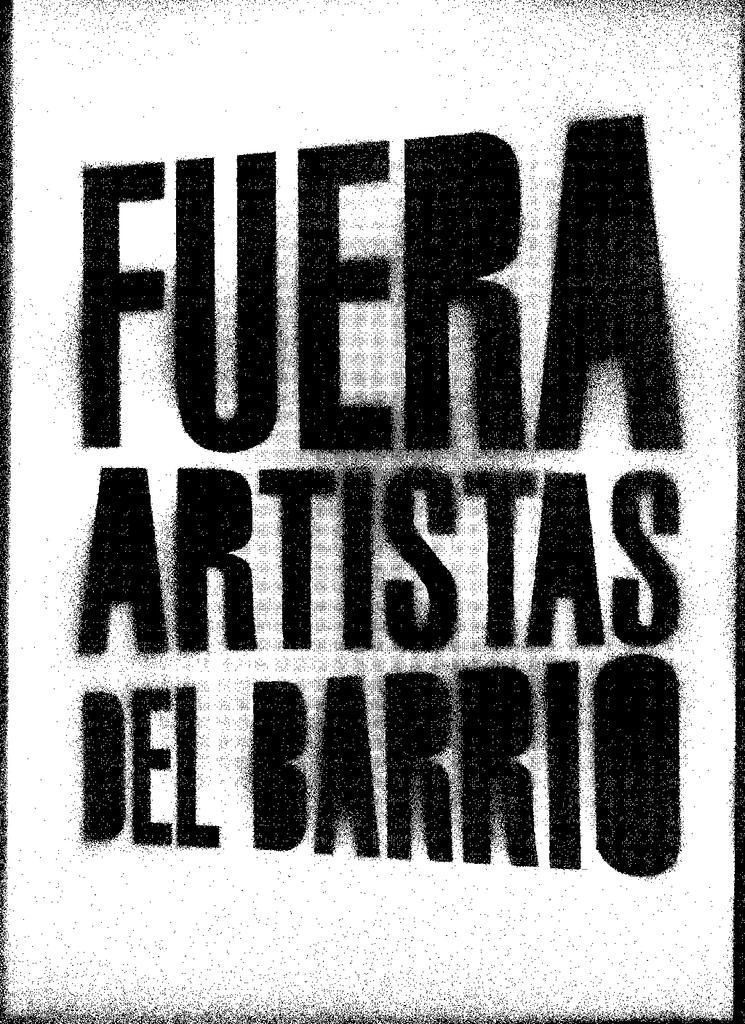<image>
Give a short and clear explanation of the subsequent image. A white background with black text that reads "fuera artistas del barrio". 